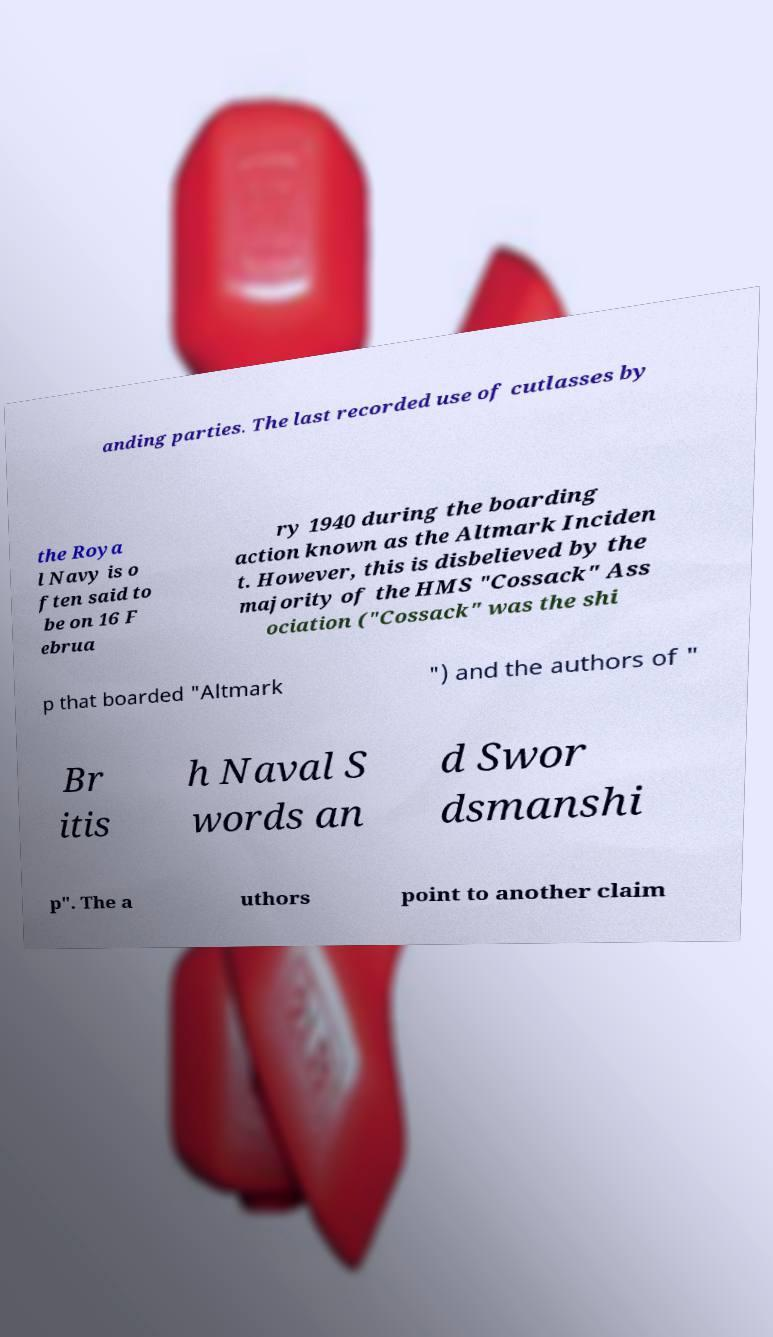Can you accurately transcribe the text from the provided image for me? anding parties. The last recorded use of cutlasses by the Roya l Navy is o ften said to be on 16 F ebrua ry 1940 during the boarding action known as the Altmark Inciden t. However, this is disbelieved by the majority of the HMS "Cossack" Ass ociation ("Cossack" was the shi p that boarded "Altmark ") and the authors of " Br itis h Naval S words an d Swor dsmanshi p". The a uthors point to another claim 